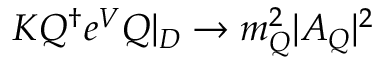Convert formula to latex. <formula><loc_0><loc_0><loc_500><loc_500>K Q ^ { \dagger } e ^ { V } Q | _ { D } \rightarrow m _ { Q } ^ { 2 } | A _ { Q } | ^ { 2 }</formula> 